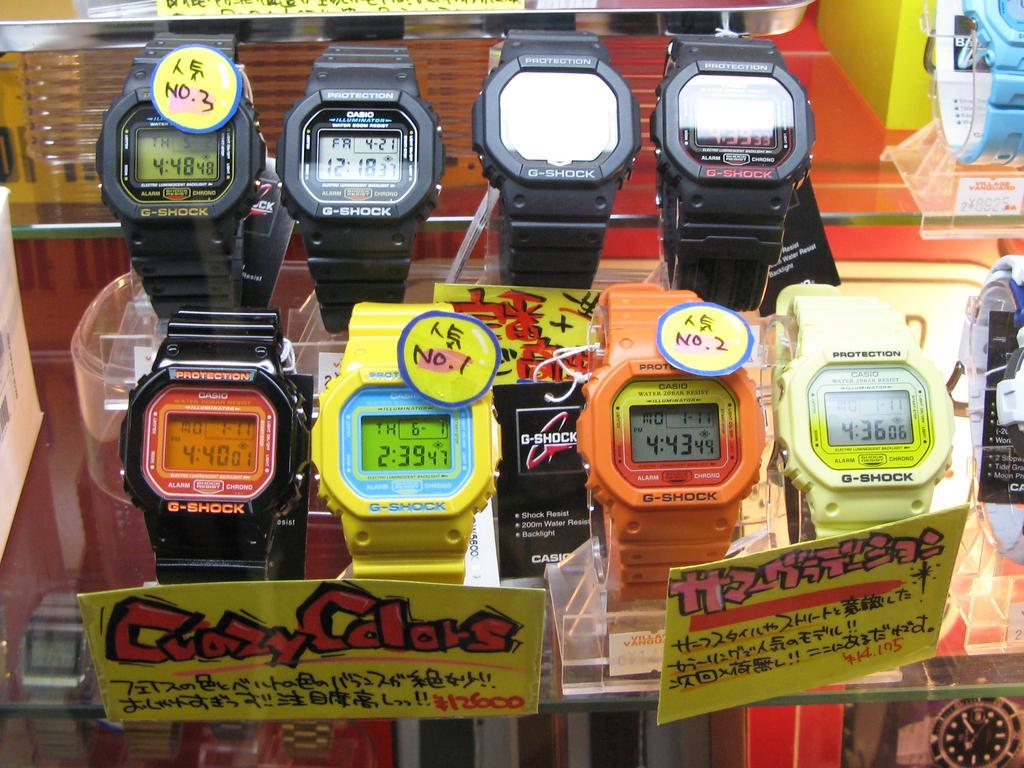Provide a one-sentence caption for the provided image. the time on a watch that says 2:39 on it. 